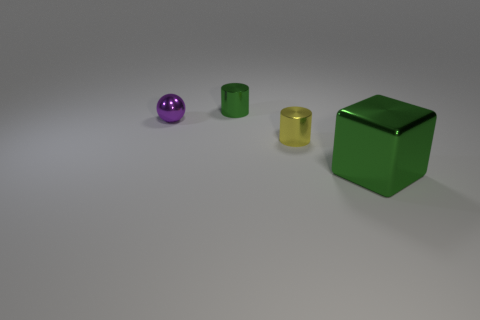There is a large green shiny thing in front of the tiny metallic object in front of the small ball; what number of green things are behind it?
Offer a terse response. 1. How many yellow objects are small objects or rubber blocks?
Your answer should be very brief. 1. There is a yellow cylinder; does it have the same size as the metal thing behind the purple ball?
Provide a short and direct response. Yes. There is a tiny green thing that is the same shape as the yellow shiny thing; what is it made of?
Provide a succinct answer. Metal. What number of other objects are there of the same size as the purple thing?
Your response must be concise. 2. There is a tiny shiny thing in front of the tiny object that is to the left of the green object that is behind the large thing; what shape is it?
Provide a succinct answer. Cylinder. The object that is both to the right of the small green metal thing and to the left of the large green block has what shape?
Provide a succinct answer. Cylinder. How many objects are either cyan cylinders or small metallic cylinders that are behind the shiny ball?
Your answer should be compact. 1. How many other objects are the same shape as the large object?
Give a very brief answer. 0. What number of metallic objects are either things or small things?
Provide a short and direct response. 4. 